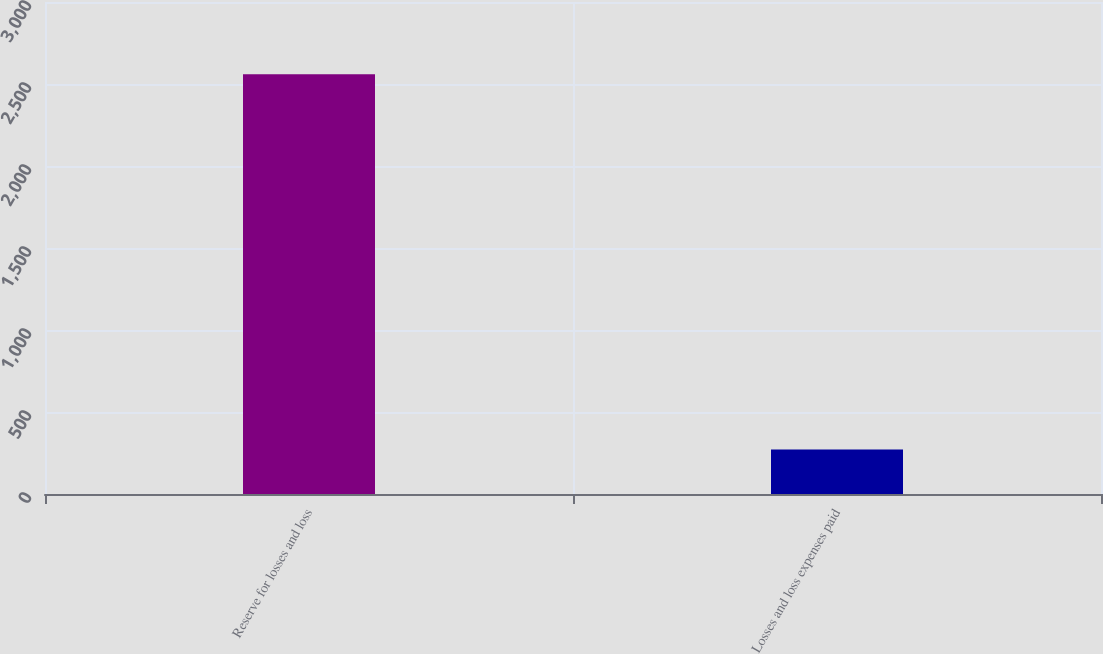Convert chart. <chart><loc_0><loc_0><loc_500><loc_500><bar_chart><fcel>Reserve for losses and loss<fcel>Losses and loss expenses paid<nl><fcel>2559<fcel>271<nl></chart> 